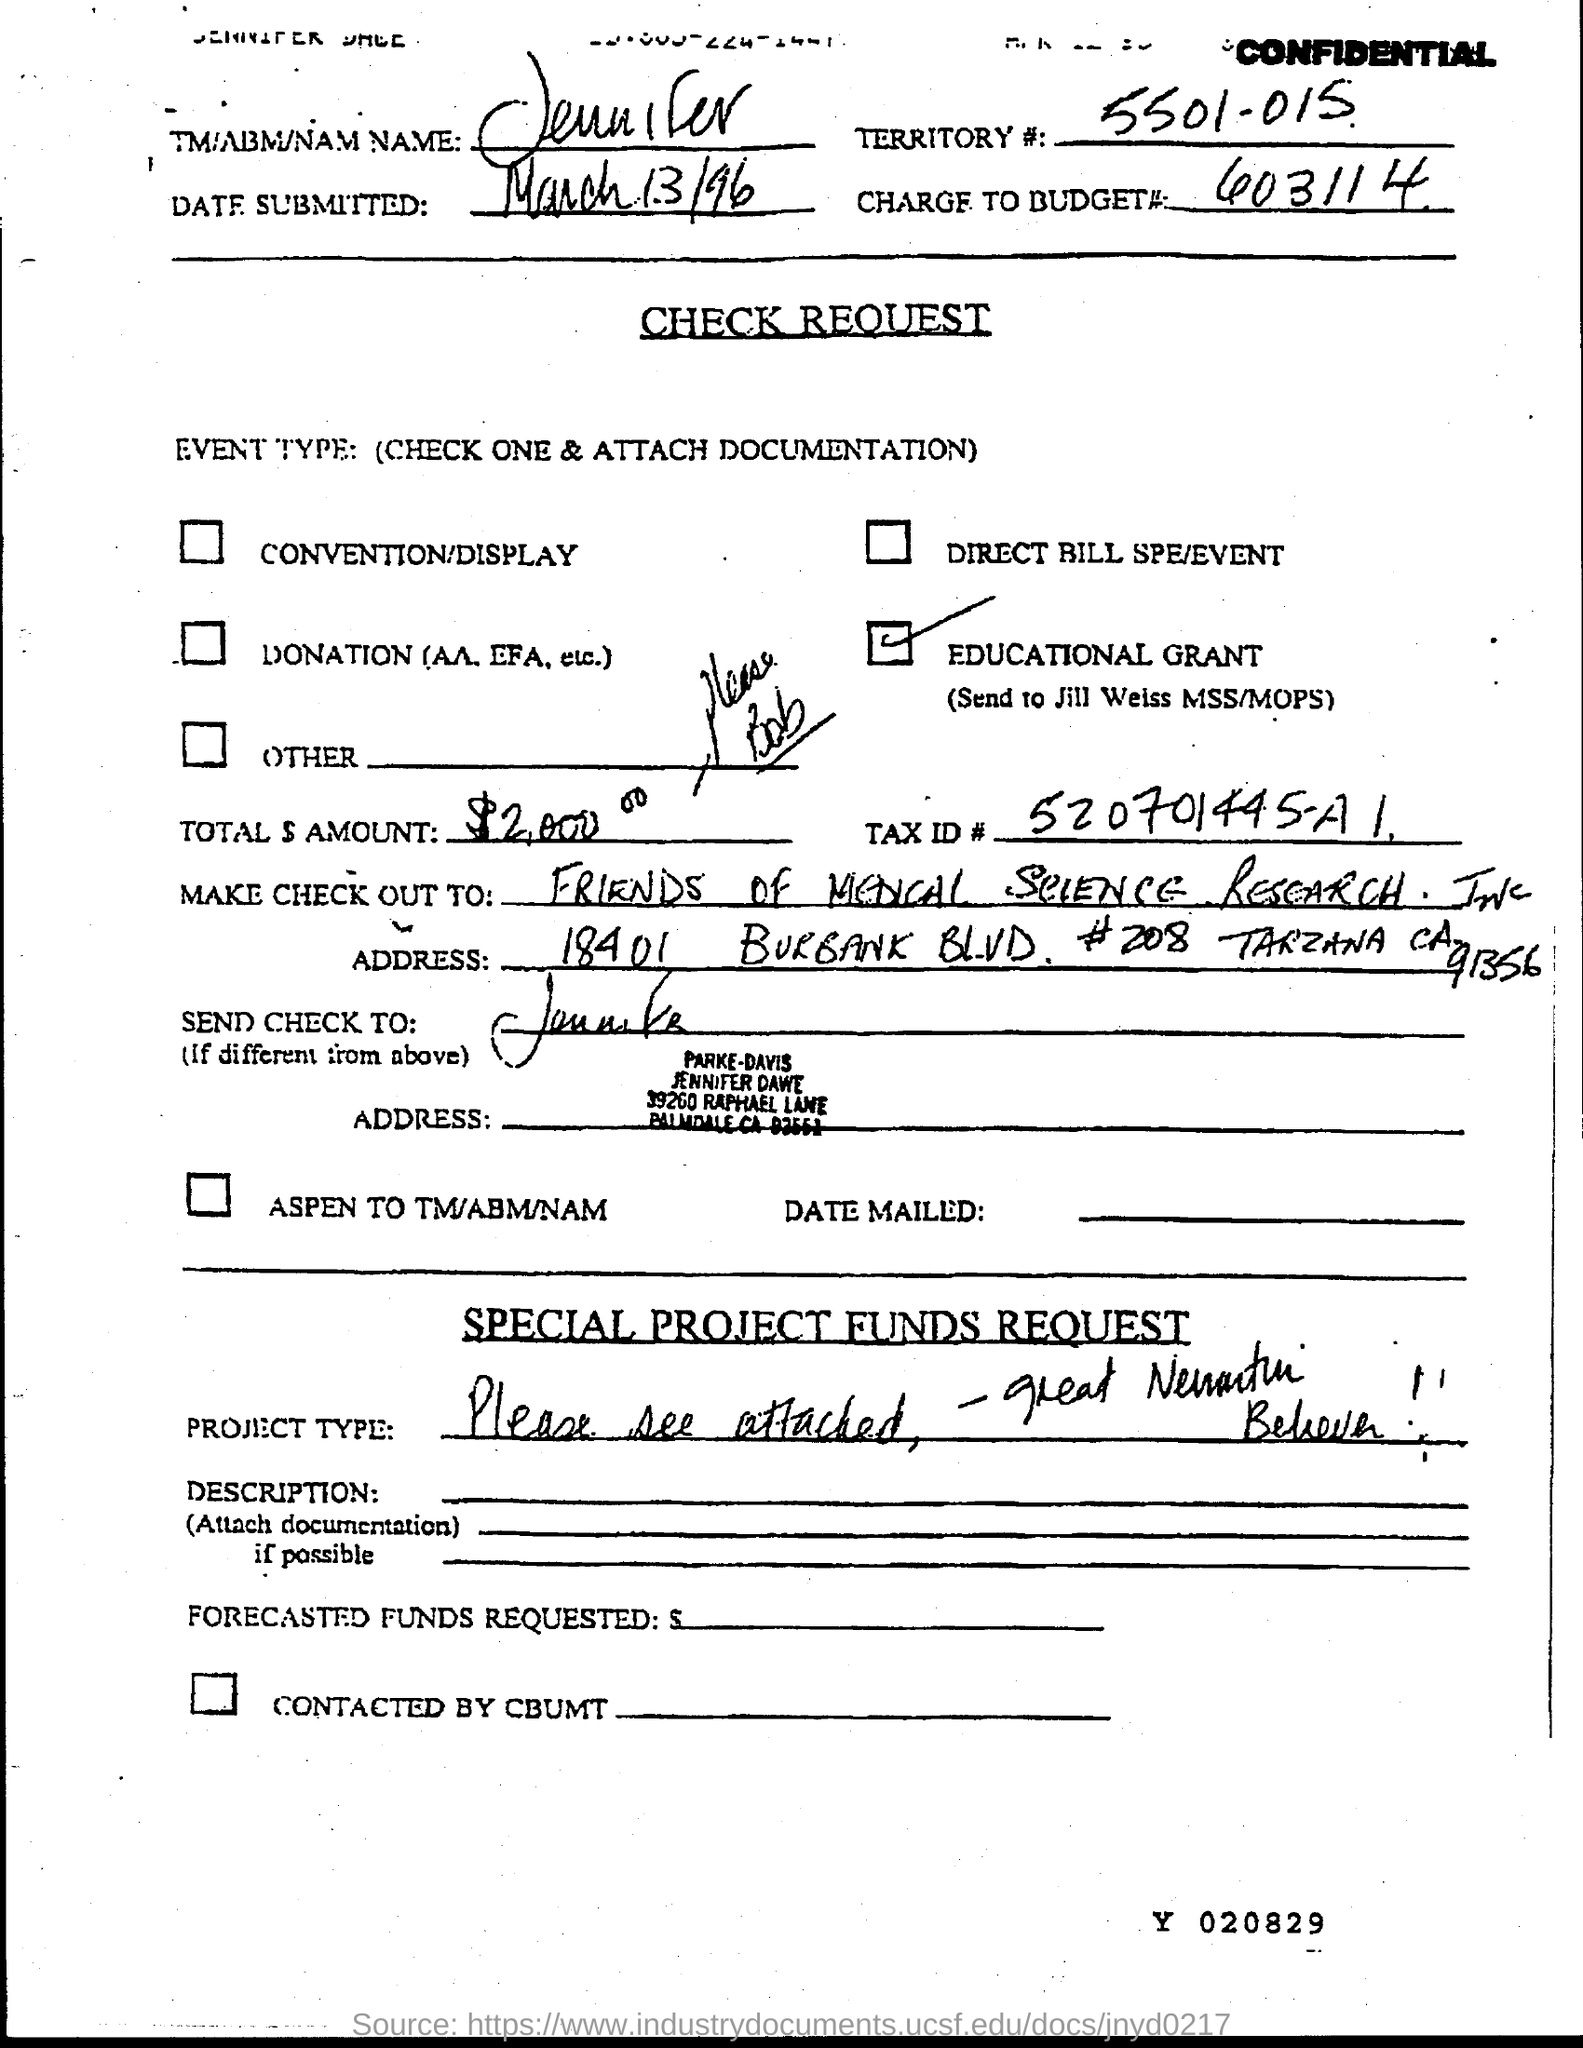What is the name given in the document?
Your response must be concise. Jennifer. What is the Territory#(no) given in the document?
Your answer should be compact. 5501-015. What is the date submitted as per the dcoument?
Keep it short and to the point. March 13/96. What is the charge to budget# (no) given in the document?
Give a very brief answer. 603114. What is the total amount given in the check request?
Make the answer very short. $2,000. What is the Tax ID# mentioned in the check request?
Provide a short and direct response. 520701445-A1. 